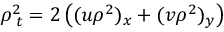<formula> <loc_0><loc_0><loc_500><loc_500>\rho _ { \, t } ^ { 2 } = 2 \left ( ( u \rho ^ { 2 } ) _ { x } + ( v \rho ^ { 2 } ) _ { y } \right )</formula> 